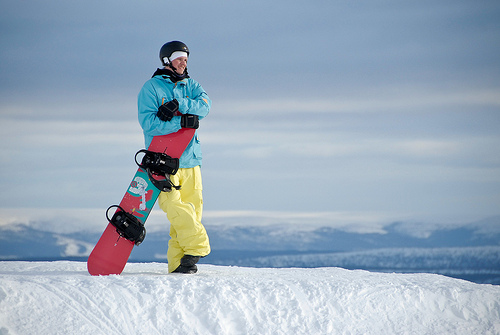Is the sky behind the snow orange and huge? The sky in the background is not orange; it appears to be a normal blue sky, indicative of clear weather conditions. 